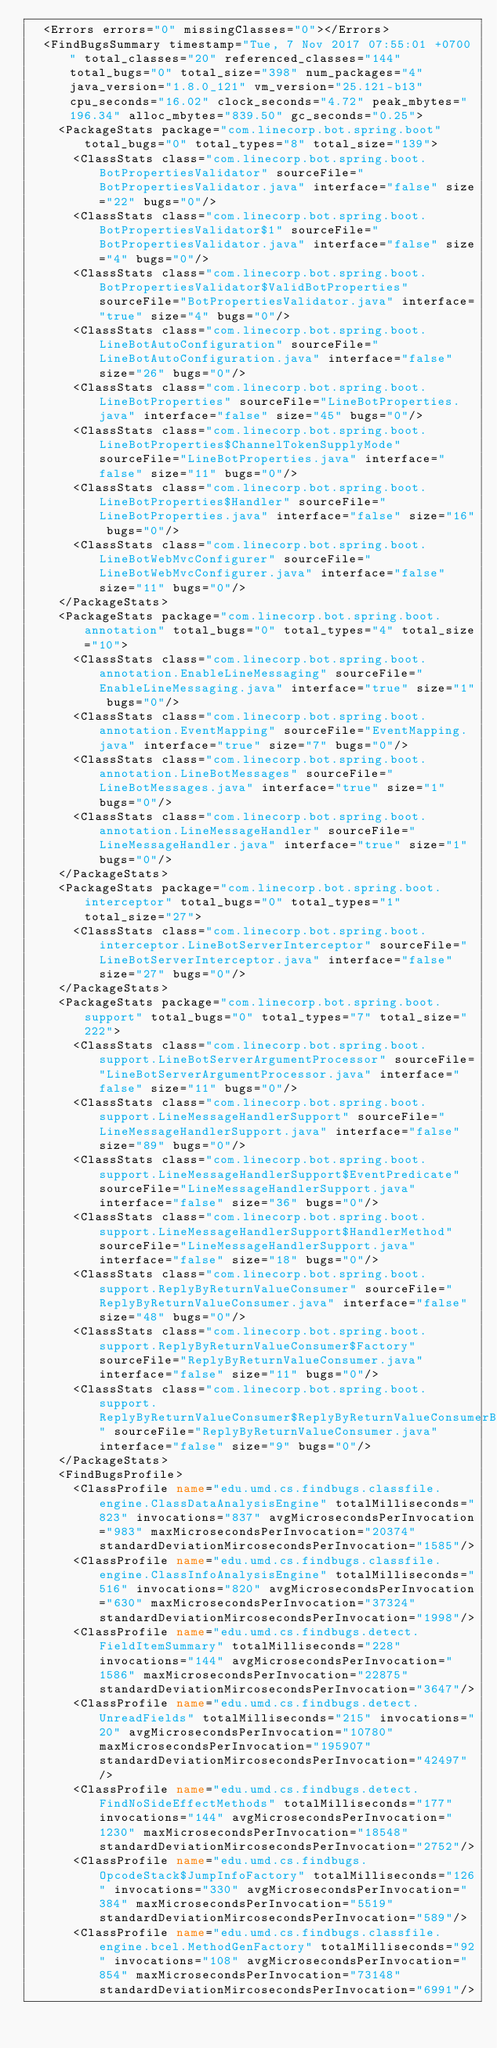Convert code to text. <code><loc_0><loc_0><loc_500><loc_500><_XML_>  <Errors errors="0" missingClasses="0"></Errors>
  <FindBugsSummary timestamp="Tue, 7 Nov 2017 07:55:01 +0700" total_classes="20" referenced_classes="144" total_bugs="0" total_size="398" num_packages="4" java_version="1.8.0_121" vm_version="25.121-b13" cpu_seconds="16.02" clock_seconds="4.72" peak_mbytes="196.34" alloc_mbytes="839.50" gc_seconds="0.25">
    <PackageStats package="com.linecorp.bot.spring.boot" total_bugs="0" total_types="8" total_size="139">
      <ClassStats class="com.linecorp.bot.spring.boot.BotPropertiesValidator" sourceFile="BotPropertiesValidator.java" interface="false" size="22" bugs="0"/>
      <ClassStats class="com.linecorp.bot.spring.boot.BotPropertiesValidator$1" sourceFile="BotPropertiesValidator.java" interface="false" size="4" bugs="0"/>
      <ClassStats class="com.linecorp.bot.spring.boot.BotPropertiesValidator$ValidBotProperties" sourceFile="BotPropertiesValidator.java" interface="true" size="4" bugs="0"/>
      <ClassStats class="com.linecorp.bot.spring.boot.LineBotAutoConfiguration" sourceFile="LineBotAutoConfiguration.java" interface="false" size="26" bugs="0"/>
      <ClassStats class="com.linecorp.bot.spring.boot.LineBotProperties" sourceFile="LineBotProperties.java" interface="false" size="45" bugs="0"/>
      <ClassStats class="com.linecorp.bot.spring.boot.LineBotProperties$ChannelTokenSupplyMode" sourceFile="LineBotProperties.java" interface="false" size="11" bugs="0"/>
      <ClassStats class="com.linecorp.bot.spring.boot.LineBotProperties$Handler" sourceFile="LineBotProperties.java" interface="false" size="16" bugs="0"/>
      <ClassStats class="com.linecorp.bot.spring.boot.LineBotWebMvcConfigurer" sourceFile="LineBotWebMvcConfigurer.java" interface="false" size="11" bugs="0"/>
    </PackageStats>
    <PackageStats package="com.linecorp.bot.spring.boot.annotation" total_bugs="0" total_types="4" total_size="10">
      <ClassStats class="com.linecorp.bot.spring.boot.annotation.EnableLineMessaging" sourceFile="EnableLineMessaging.java" interface="true" size="1" bugs="0"/>
      <ClassStats class="com.linecorp.bot.spring.boot.annotation.EventMapping" sourceFile="EventMapping.java" interface="true" size="7" bugs="0"/>
      <ClassStats class="com.linecorp.bot.spring.boot.annotation.LineBotMessages" sourceFile="LineBotMessages.java" interface="true" size="1" bugs="0"/>
      <ClassStats class="com.linecorp.bot.spring.boot.annotation.LineMessageHandler" sourceFile="LineMessageHandler.java" interface="true" size="1" bugs="0"/>
    </PackageStats>
    <PackageStats package="com.linecorp.bot.spring.boot.interceptor" total_bugs="0" total_types="1" total_size="27">
      <ClassStats class="com.linecorp.bot.spring.boot.interceptor.LineBotServerInterceptor" sourceFile="LineBotServerInterceptor.java" interface="false" size="27" bugs="0"/>
    </PackageStats>
    <PackageStats package="com.linecorp.bot.spring.boot.support" total_bugs="0" total_types="7" total_size="222">
      <ClassStats class="com.linecorp.bot.spring.boot.support.LineBotServerArgumentProcessor" sourceFile="LineBotServerArgumentProcessor.java" interface="false" size="11" bugs="0"/>
      <ClassStats class="com.linecorp.bot.spring.boot.support.LineMessageHandlerSupport" sourceFile="LineMessageHandlerSupport.java" interface="false" size="89" bugs="0"/>
      <ClassStats class="com.linecorp.bot.spring.boot.support.LineMessageHandlerSupport$EventPredicate" sourceFile="LineMessageHandlerSupport.java" interface="false" size="36" bugs="0"/>
      <ClassStats class="com.linecorp.bot.spring.boot.support.LineMessageHandlerSupport$HandlerMethod" sourceFile="LineMessageHandlerSupport.java" interface="false" size="18" bugs="0"/>
      <ClassStats class="com.linecorp.bot.spring.boot.support.ReplyByReturnValueConsumer" sourceFile="ReplyByReturnValueConsumer.java" interface="false" size="48" bugs="0"/>
      <ClassStats class="com.linecorp.bot.spring.boot.support.ReplyByReturnValueConsumer$Factory" sourceFile="ReplyByReturnValueConsumer.java" interface="false" size="11" bugs="0"/>
      <ClassStats class="com.linecorp.bot.spring.boot.support.ReplyByReturnValueConsumer$ReplyByReturnValueConsumerBuilder" sourceFile="ReplyByReturnValueConsumer.java" interface="false" size="9" bugs="0"/>
    </PackageStats>
    <FindBugsProfile>
      <ClassProfile name="edu.umd.cs.findbugs.classfile.engine.ClassDataAnalysisEngine" totalMilliseconds="823" invocations="837" avgMicrosecondsPerInvocation="983" maxMicrosecondsPerInvocation="20374" standardDeviationMircosecondsPerInvocation="1585"/>
      <ClassProfile name="edu.umd.cs.findbugs.classfile.engine.ClassInfoAnalysisEngine" totalMilliseconds="516" invocations="820" avgMicrosecondsPerInvocation="630" maxMicrosecondsPerInvocation="37324" standardDeviationMircosecondsPerInvocation="1998"/>
      <ClassProfile name="edu.umd.cs.findbugs.detect.FieldItemSummary" totalMilliseconds="228" invocations="144" avgMicrosecondsPerInvocation="1586" maxMicrosecondsPerInvocation="22875" standardDeviationMircosecondsPerInvocation="3647"/>
      <ClassProfile name="edu.umd.cs.findbugs.detect.UnreadFields" totalMilliseconds="215" invocations="20" avgMicrosecondsPerInvocation="10780" maxMicrosecondsPerInvocation="195907" standardDeviationMircosecondsPerInvocation="42497"/>
      <ClassProfile name="edu.umd.cs.findbugs.detect.FindNoSideEffectMethods" totalMilliseconds="177" invocations="144" avgMicrosecondsPerInvocation="1230" maxMicrosecondsPerInvocation="18548" standardDeviationMircosecondsPerInvocation="2752"/>
      <ClassProfile name="edu.umd.cs.findbugs.OpcodeStack$JumpInfoFactory" totalMilliseconds="126" invocations="330" avgMicrosecondsPerInvocation="384" maxMicrosecondsPerInvocation="5519" standardDeviationMircosecondsPerInvocation="589"/>
      <ClassProfile name="edu.umd.cs.findbugs.classfile.engine.bcel.MethodGenFactory" totalMilliseconds="92" invocations="108" avgMicrosecondsPerInvocation="854" maxMicrosecondsPerInvocation="73148" standardDeviationMircosecondsPerInvocation="6991"/></code> 